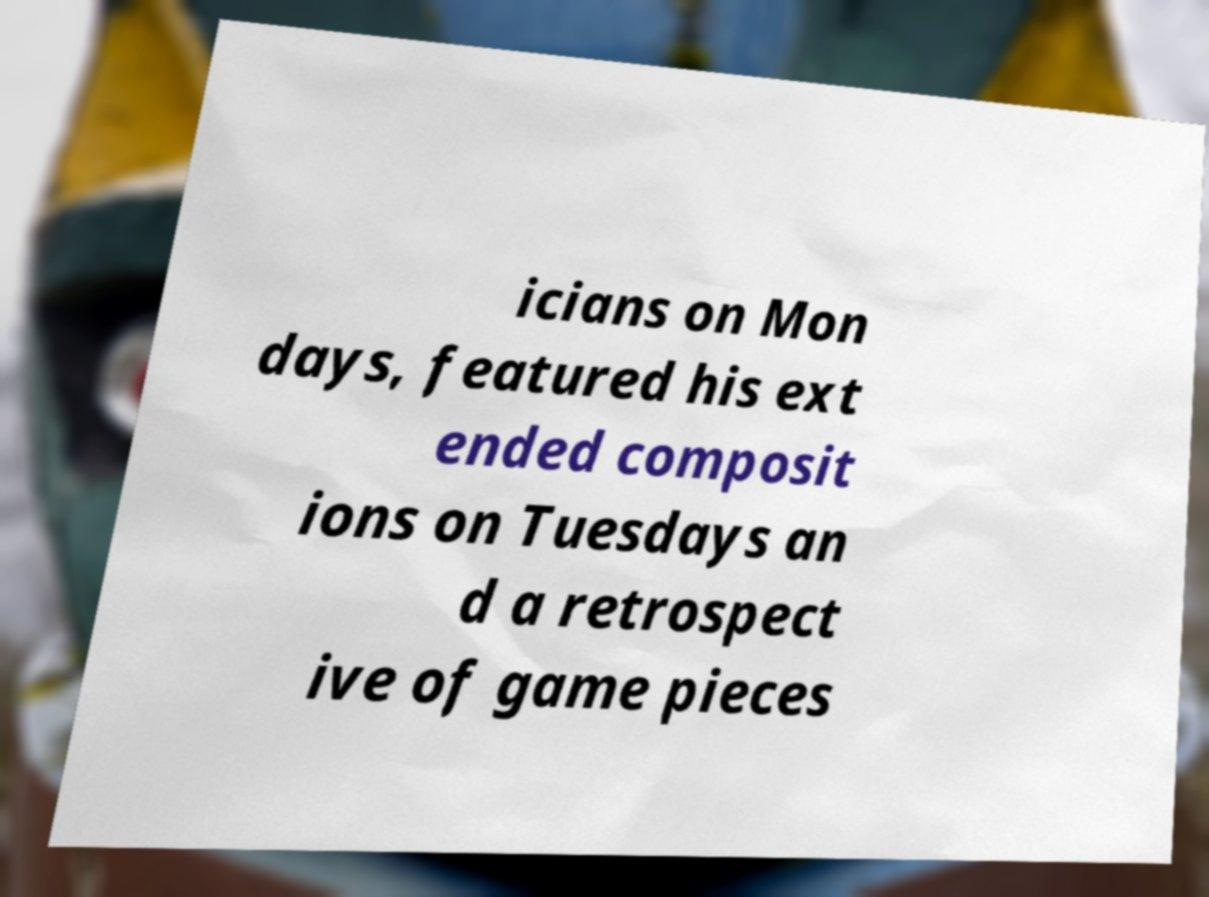What messages or text are displayed in this image? I need them in a readable, typed format. icians on Mon days, featured his ext ended composit ions on Tuesdays an d a retrospect ive of game pieces 